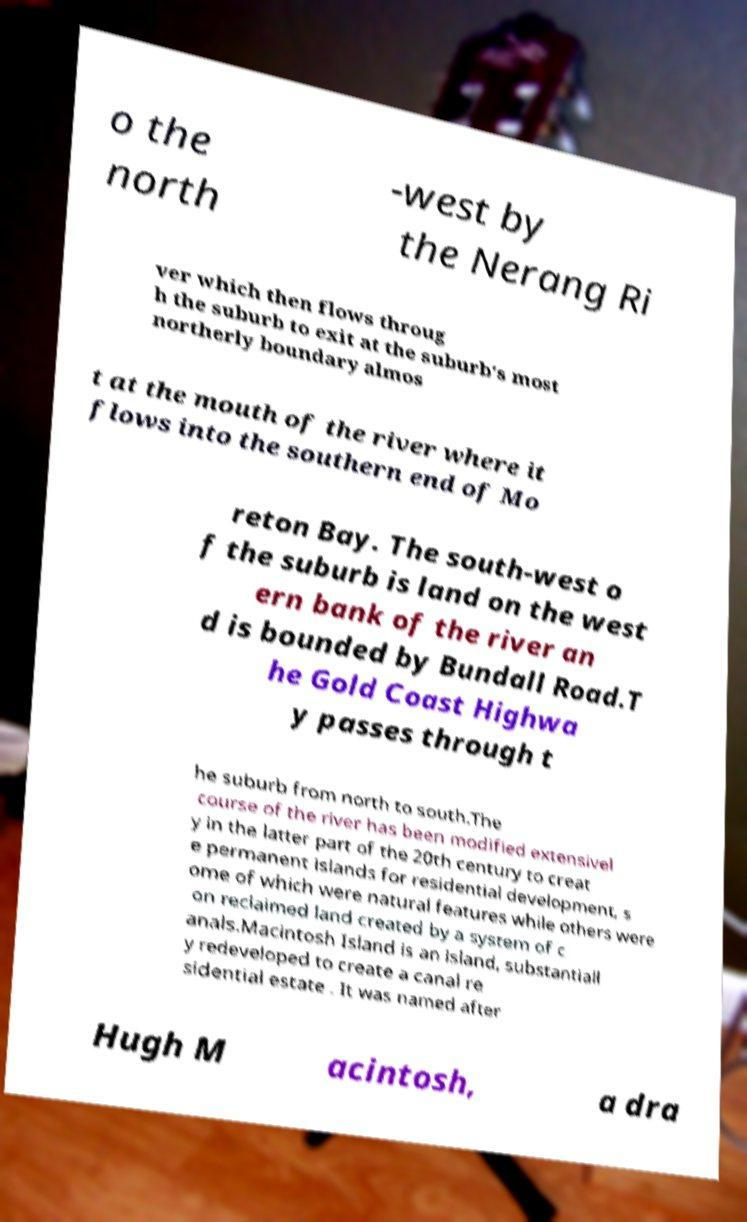There's text embedded in this image that I need extracted. Can you transcribe it verbatim? o the north -west by the Nerang Ri ver which then flows throug h the suburb to exit at the suburb's most northerly boundary almos t at the mouth of the river where it flows into the southern end of Mo reton Bay. The south-west o f the suburb is land on the west ern bank of the river an d is bounded by Bundall Road.T he Gold Coast Highwa y passes through t he suburb from north to south.The course of the river has been modified extensivel y in the latter part of the 20th century to creat e permanent islands for residential development, s ome of which were natural features while others were on reclaimed land created by a system of c anals.Macintosh Island is an island, substantiall y redeveloped to create a canal re sidential estate . It was named after Hugh M acintosh, a dra 